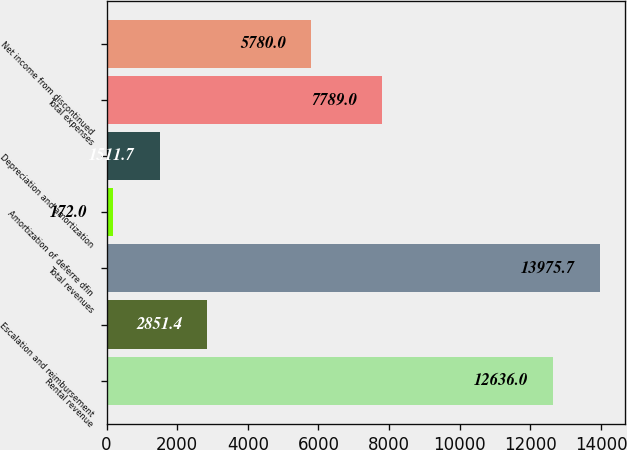<chart> <loc_0><loc_0><loc_500><loc_500><bar_chart><fcel>Rental revenue<fcel>Escalation and reimbursement<fcel>Total revenues<fcel>Amortization of deferre dfin<fcel>Depreciation and amortization<fcel>Total expenses<fcel>Net income from discontinued<nl><fcel>12636<fcel>2851.4<fcel>13975.7<fcel>172<fcel>1511.7<fcel>7789<fcel>5780<nl></chart> 